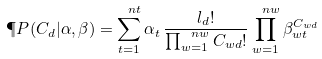<formula> <loc_0><loc_0><loc_500><loc_500>\P P ( C _ { d } | \alpha , \beta ) = \sum _ { t = 1 } ^ { \ n t } \alpha _ { t } \, \frac { l _ { d } ! } { \prod _ { w = 1 } ^ { \ n w } C _ { w d } ! } \prod _ { w = 1 } ^ { \ n w } \beta _ { w t } ^ { C _ { w d } }</formula> 